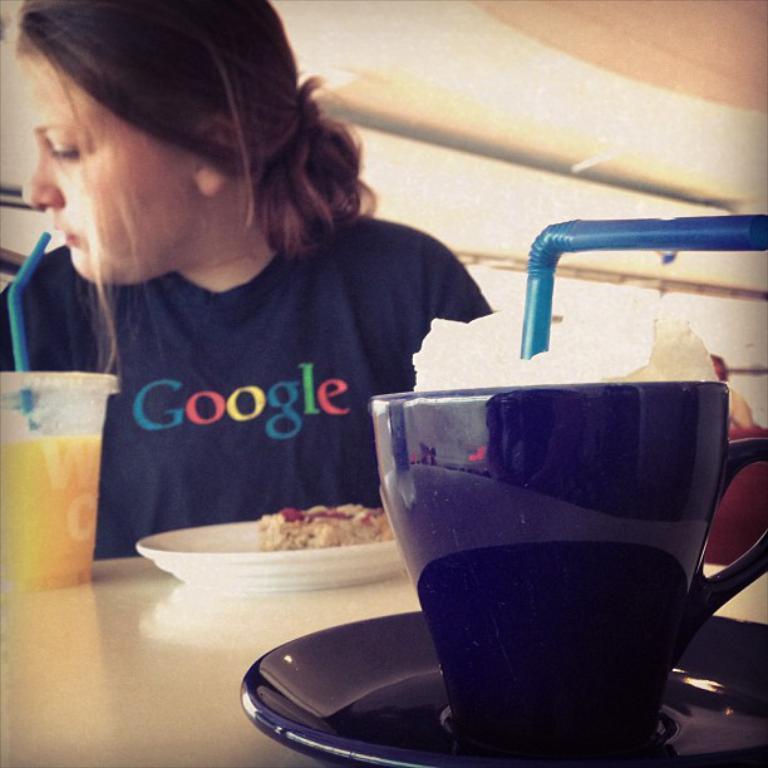Please provide a concise description of this image. In this picture there is a woman sitting behind the table. There are cups and there is a plate, saucer on the table and there is a food on the plate. At the back there is a person. At the top there are lights. 